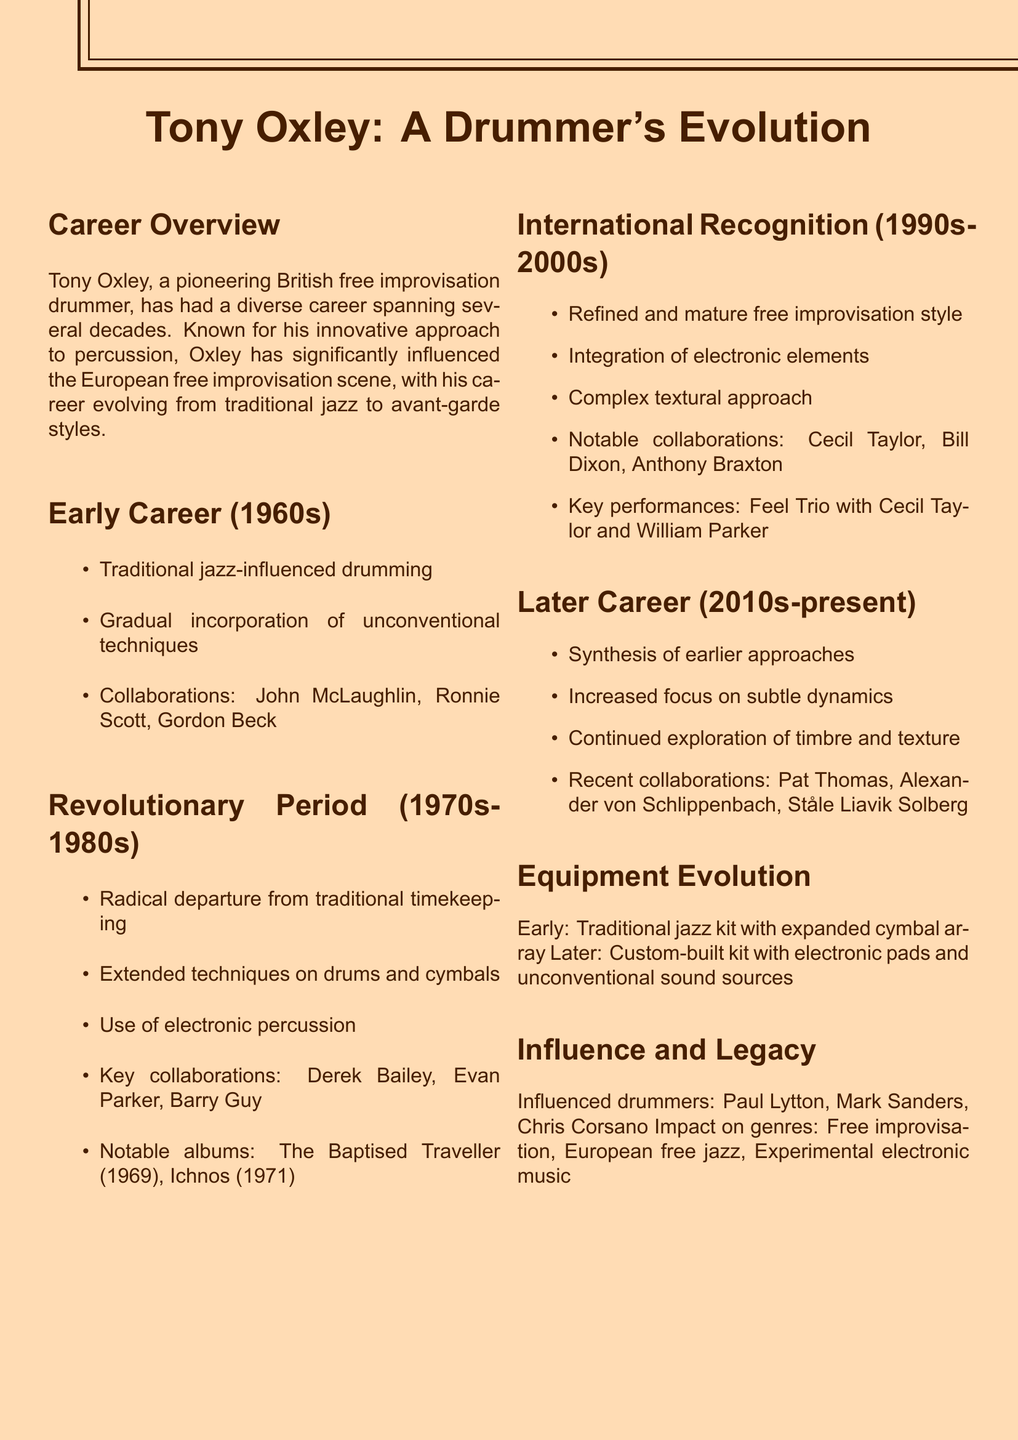What drumming style was characteristic of Tony Oxley in the 1960s? The 1960s style was influenced by traditional jazz, gradually integrating unconventional techniques.
Answer: Traditional jazz-influenced drumming Name a notable collaboration from Tony Oxley's revolutionary period. The revolutionary period featured collaborations with notable artists like Derek Bailey and Evan Parker.
Answer: Derek Bailey What was a key album released in the 1970s? "The Baptised Traveller" and "Ichnos" are highlighted as significant albums from this period.
Answer: The Baptised Traveller Which element was integrated into Oxley's drumming style in the 1990s-2000s? The integration of electronic elements marked his refined free improvisation style during this era.
Answer: Electronic elements Identify a notable collaboration from Oxley's later career. Recent collaborations list artists like Pat Thomas and Alexander von Schlippenbach.
Answer: Pat Thomas What equipment change occurred from Oxley's early setup to his later setup? The shift involved moving from a traditional jazz kit to a custom-built kit with electronic components.
Answer: Custom-built drum kit How did Oxley's approach to drumming change in his later career? The later career showed a synthesis of earlier styles with an increased focus on subtle dynamics.
Answer: Subtle dynamics Which drummers were influenced by Tony Oxley? The document mentions Paul Lytton, Mark Sanders, and Chris Corsano as influenced by Oxley.
Answer: Paul Lytton What impact did Tony Oxley have on music genres? His influence extended to several genres, particularly free improvisation and European free jazz.
Answer: Free improvisation 